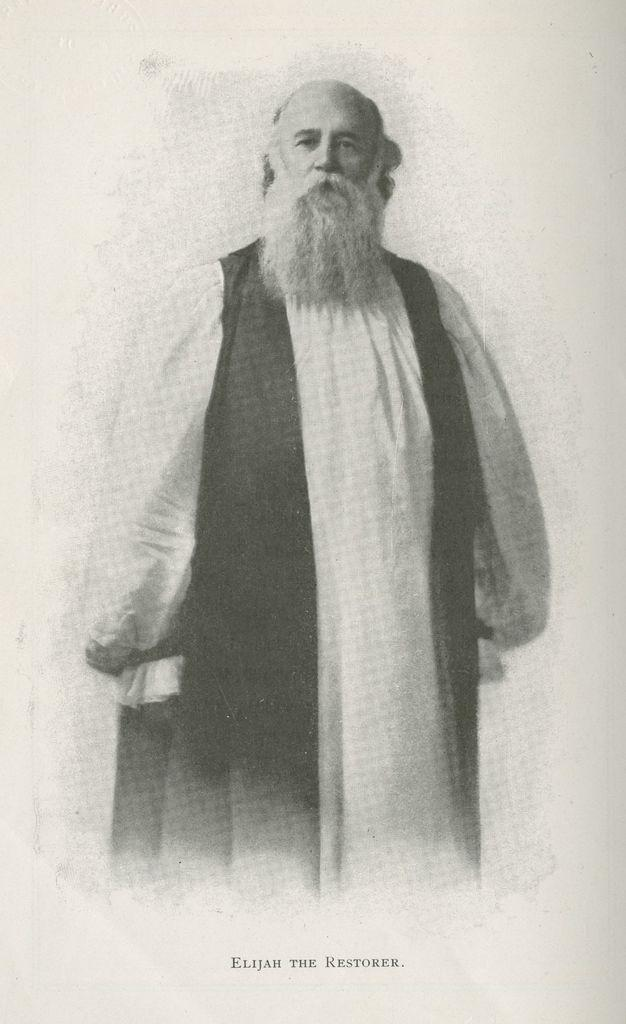Who is present in the image? There is a man in the image. What is the man wearing? The man is wearing a white and black dress. Can you describe any additional features of the image? There is a watermark on the bottom of the image. How many cups are on the table next to the man in the image? There is no table or cups present in the image; it only features a man wearing a white and black dress. 